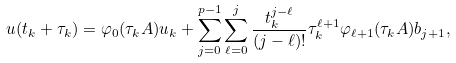Convert formula to latex. <formula><loc_0><loc_0><loc_500><loc_500>u ( t _ { k } + \tau _ { k } ) = \varphi _ { 0 } ( \tau _ { k } A ) u _ { k } + \sum _ { j = 0 } ^ { p - 1 } \sum _ { \ell = 0 } ^ { j } \frac { t _ { k } ^ { j - \ell } } { ( j - \ell ) ! } \tau _ { k } ^ { \ell + 1 } \varphi _ { \ell + 1 } ( \tau _ { k } A ) b _ { j + 1 } ,</formula> 